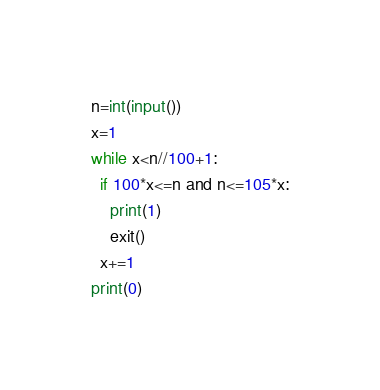Convert code to text. <code><loc_0><loc_0><loc_500><loc_500><_Python_>n=int(input())
x=1
while x<n//100+1:
  if 100*x<=n and n<=105*x:
    print(1)
    exit()
  x+=1
print(0)</code> 